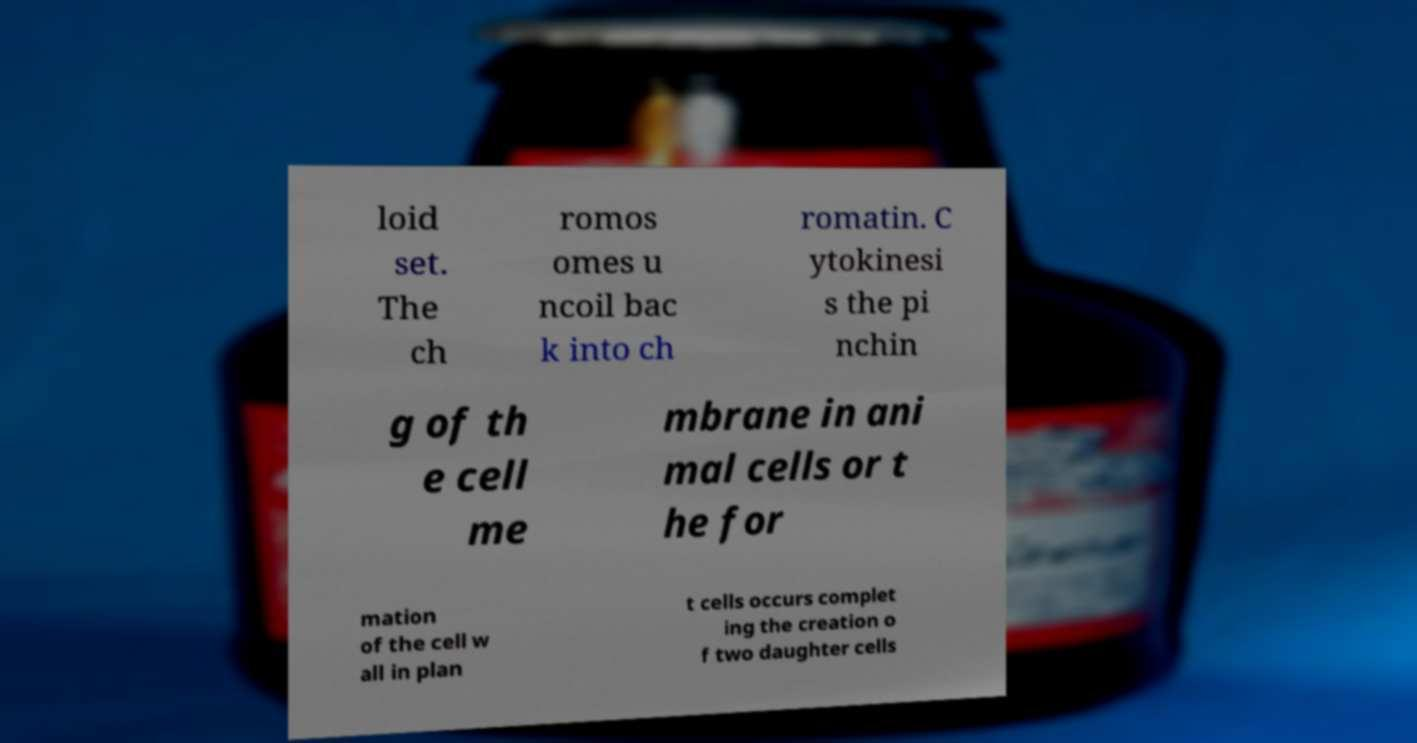Can you read and provide the text displayed in the image?This photo seems to have some interesting text. Can you extract and type it out for me? loid set. The ch romos omes u ncoil bac k into ch romatin. C ytokinesi s the pi nchin g of th e cell me mbrane in ani mal cells or t he for mation of the cell w all in plan t cells occurs complet ing the creation o f two daughter cells 